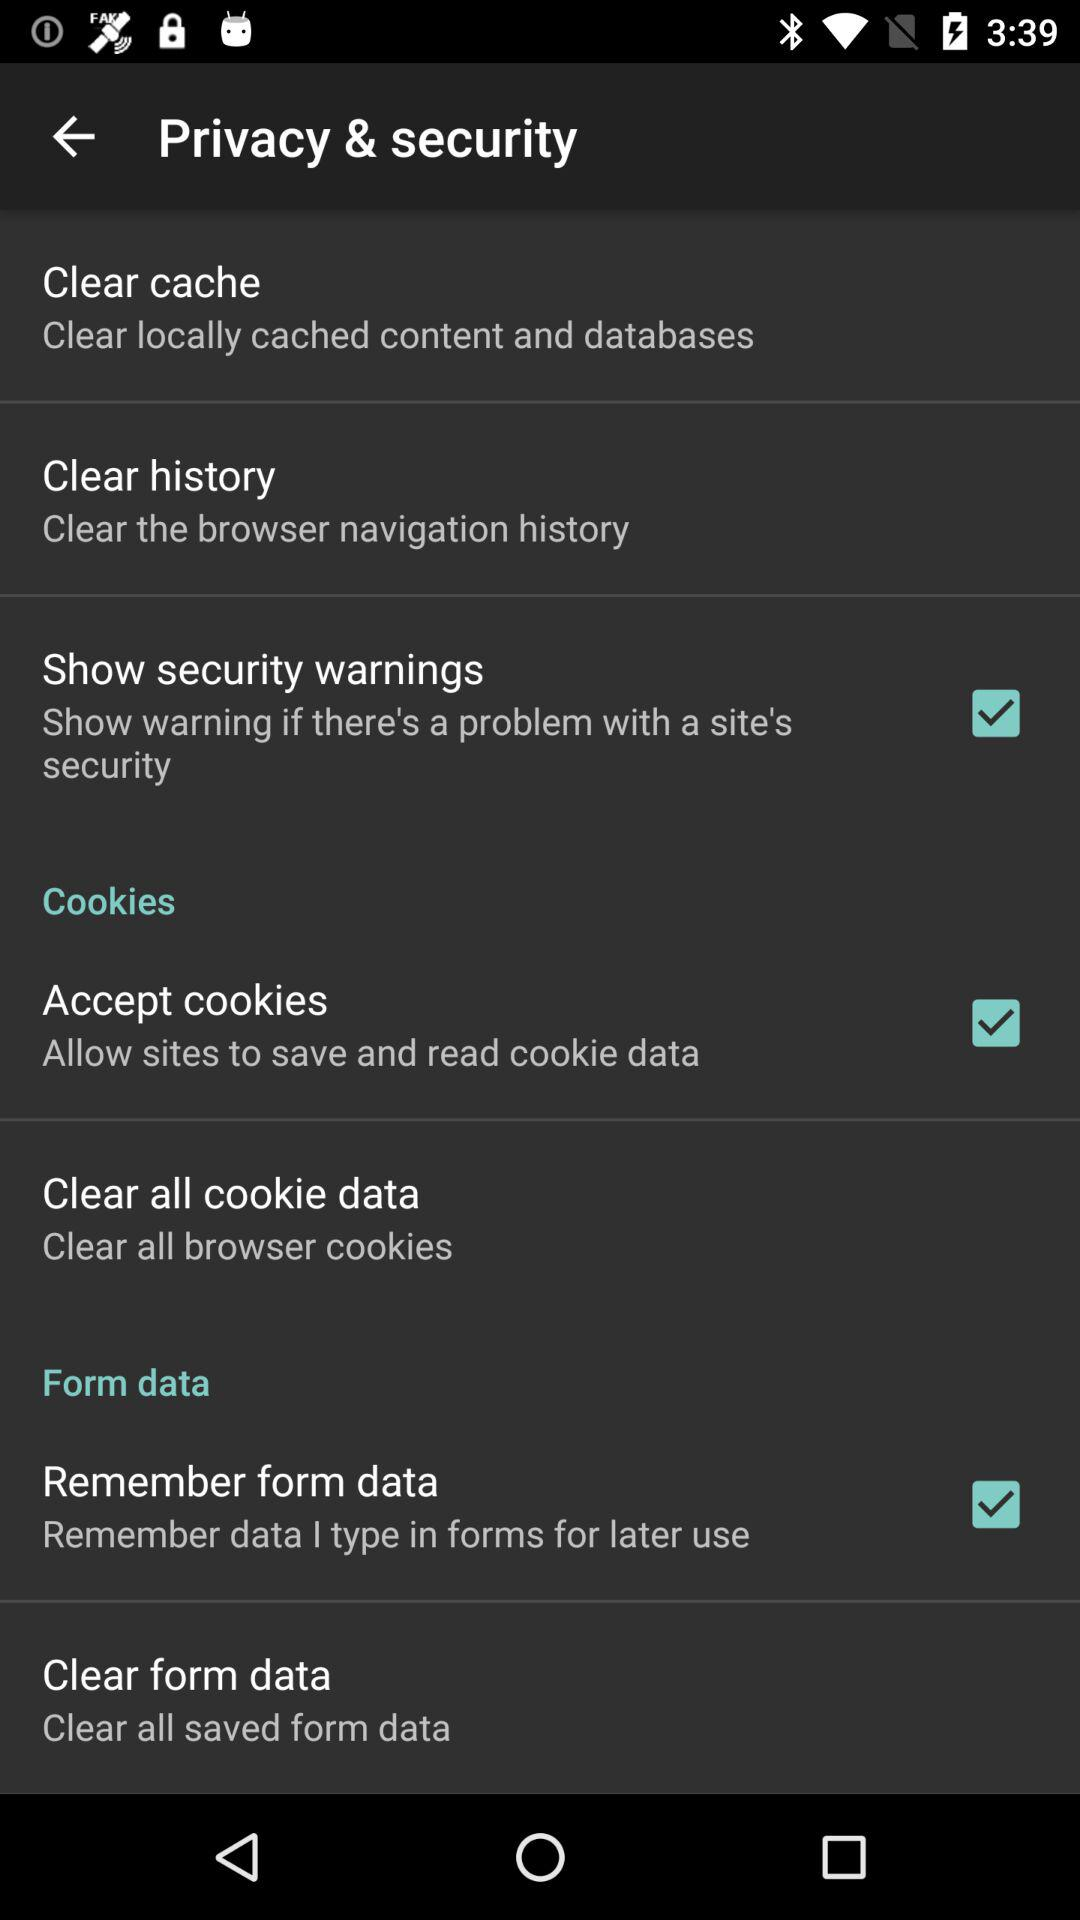What is the status of "Accept cookies"? The status of "Accept cookies" is "on". 